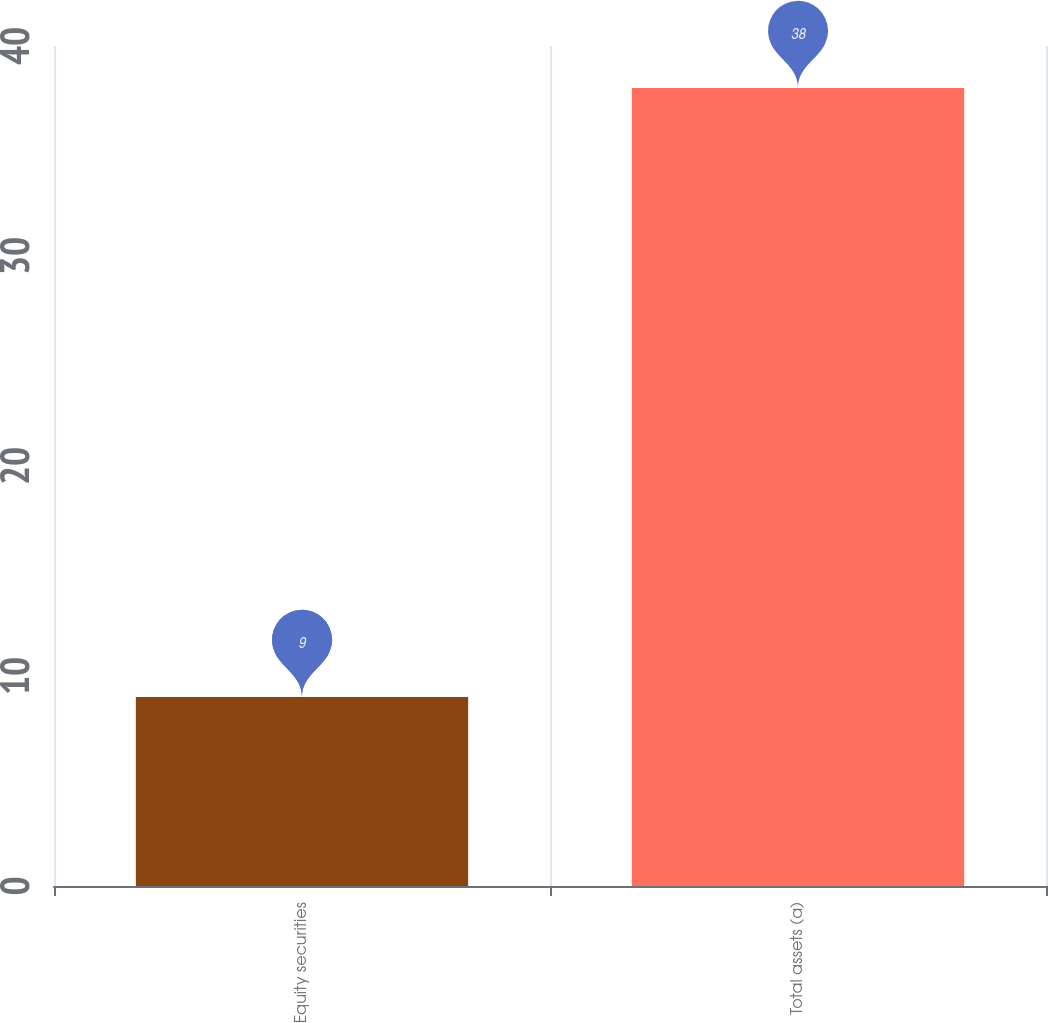<chart> <loc_0><loc_0><loc_500><loc_500><bar_chart><fcel>Equity securities<fcel>Total assets (a)<nl><fcel>9<fcel>38<nl></chart> 